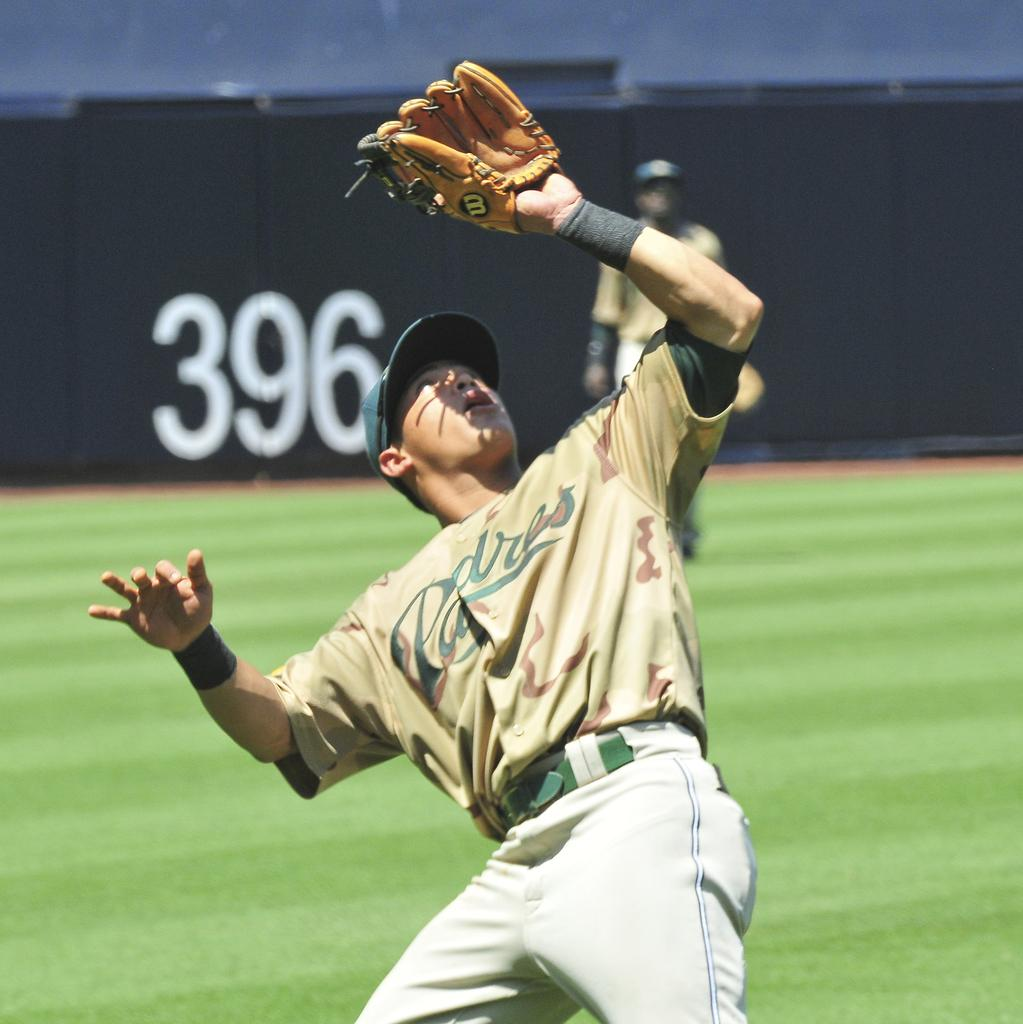<image>
Create a compact narrative representing the image presented. A baseball player has his glove up on the air and A jersey on that says Padres. 